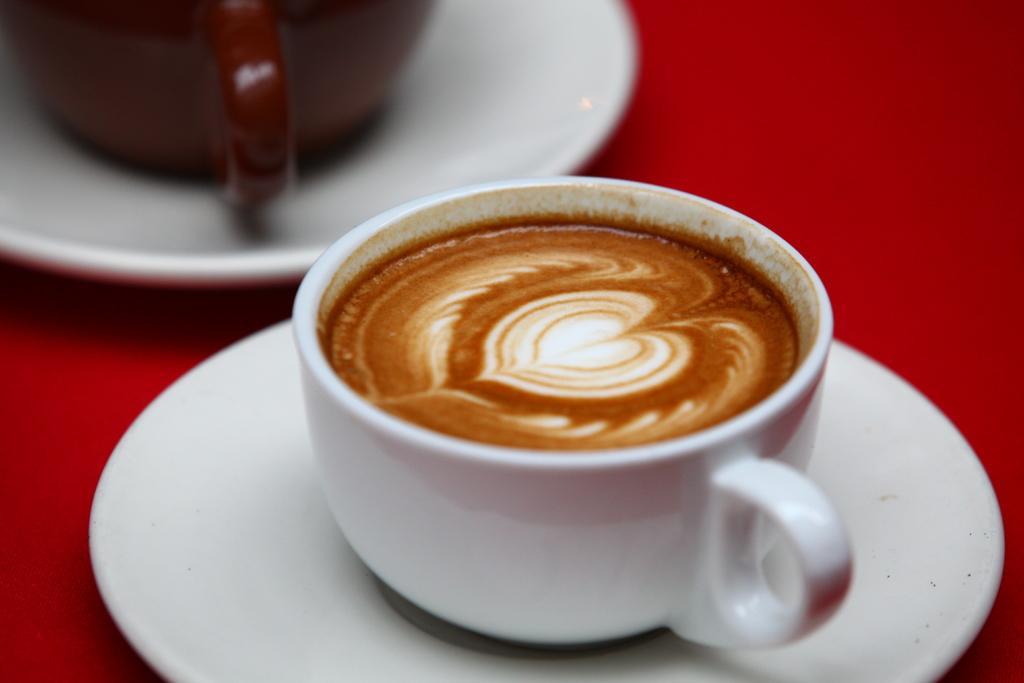Describe this image in one or two sentences. In this image I can see saucers and coffee cups are on the red surface. 